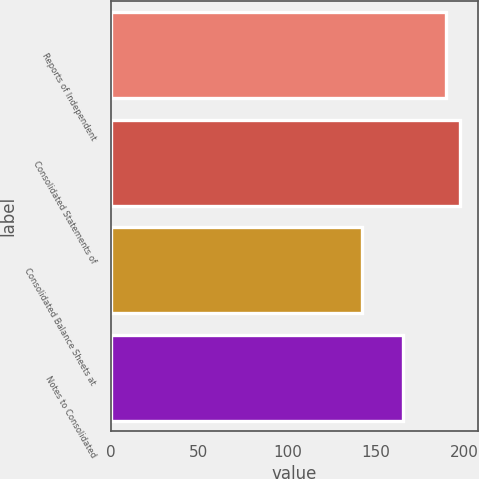<chart> <loc_0><loc_0><loc_500><loc_500><bar_chart><fcel>Reports of Independent<fcel>Consolidated Statements of<fcel>Consolidated Balance Sheets at<fcel>Notes to Consolidated<nl><fcel>190<fcel>197.7<fcel>142.1<fcel>165.2<nl></chart> 